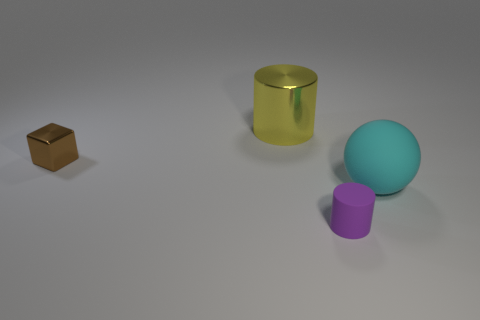Add 1 small blocks. How many objects exist? 5 Subtract 1 cylinders. How many cylinders are left? 1 Subtract all cubes. How many objects are left? 3 Add 1 purple matte cylinders. How many purple matte cylinders exist? 2 Subtract 0 blue blocks. How many objects are left? 4 Subtract all gray balls. Subtract all green cubes. How many balls are left? 1 Subtract all brown things. Subtract all big cyan things. How many objects are left? 2 Add 1 big yellow objects. How many big yellow objects are left? 2 